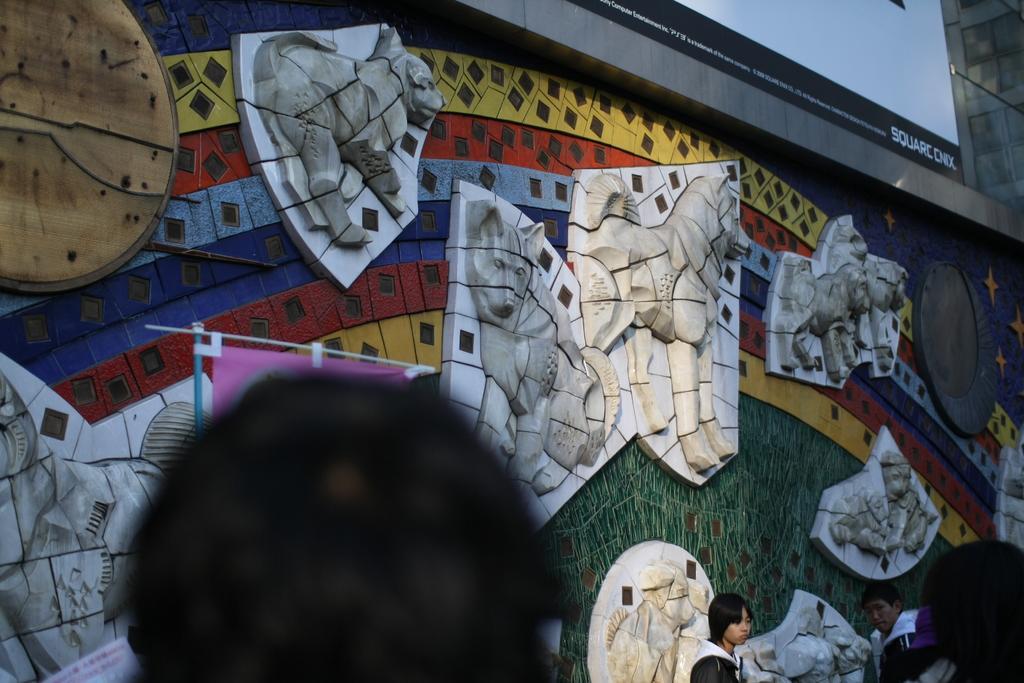In one or two sentences, can you explain what this image depicts? In this image there are persons standing towards the bottom of the image, there is a board towards the top of the image, there is text on the board, at the background of the image there is a wall, there are objects on the wall. 